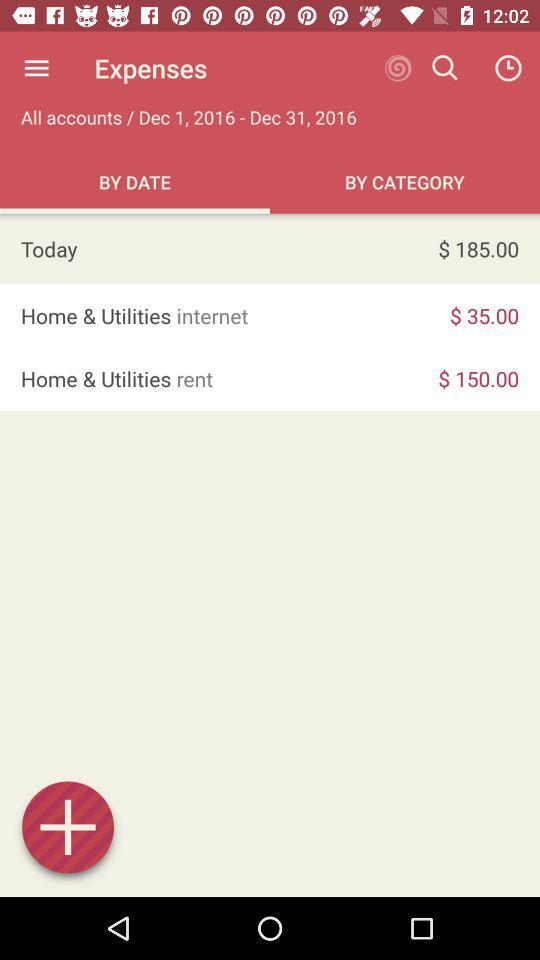How much more money was spent on rent than internet?
Answer the question using a single word or phrase. $115.00 